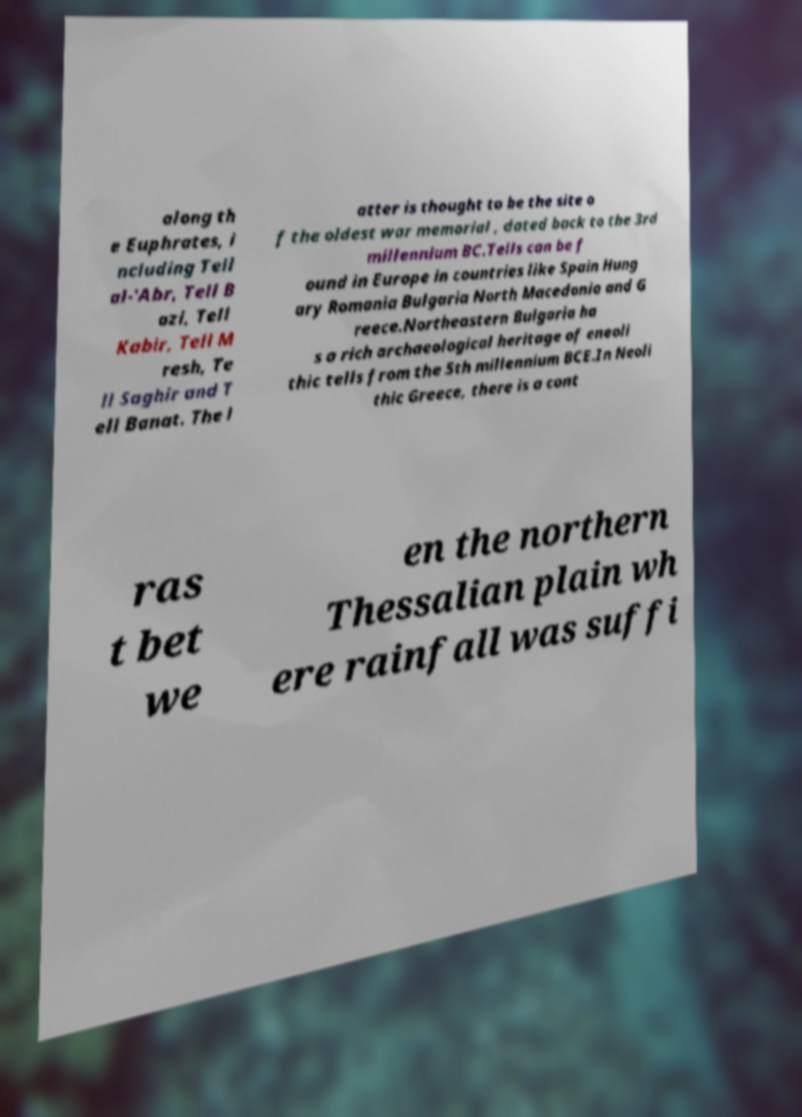Please read and relay the text visible in this image. What does it say? along th e Euphrates, i ncluding Tell al-'Abr, Tell B azi, Tell Kabir, Tell M resh, Te ll Saghir and T ell Banat. The l atter is thought to be the site o f the oldest war memorial , dated back to the 3rd millennium BC.Tells can be f ound in Europe in countries like Spain Hung ary Romania Bulgaria North Macedonia and G reece.Northeastern Bulgaria ha s a rich archaeological heritage of eneoli thic tells from the 5th millennium BCE.In Neoli thic Greece, there is a cont ras t bet we en the northern Thessalian plain wh ere rainfall was suffi 